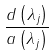<formula> <loc_0><loc_0><loc_500><loc_500>\frac { d \left ( \lambda _ { j } \right ) } { a \left ( \lambda _ { j } \right ) }</formula> 